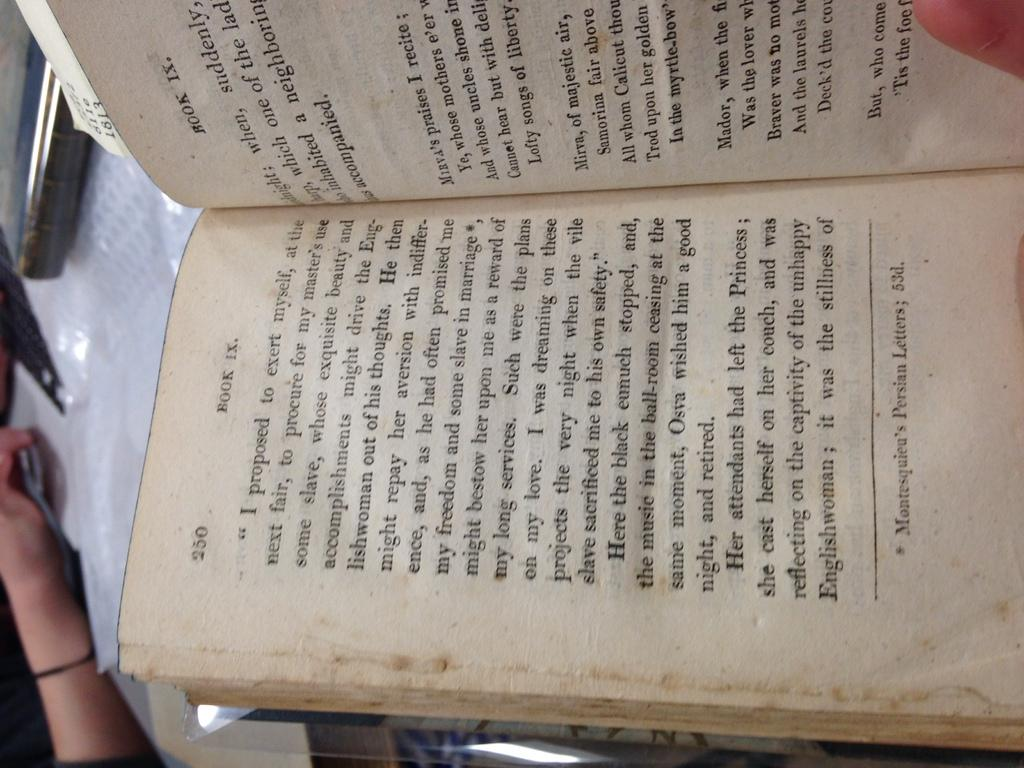What is depicted in the image? There are pages of a book in the image. What can be found on the pages of the book? There are words written on the pages. What type of coast can be seen in the image? There is no coast present in the image; it features pages of a book with words written on them. 